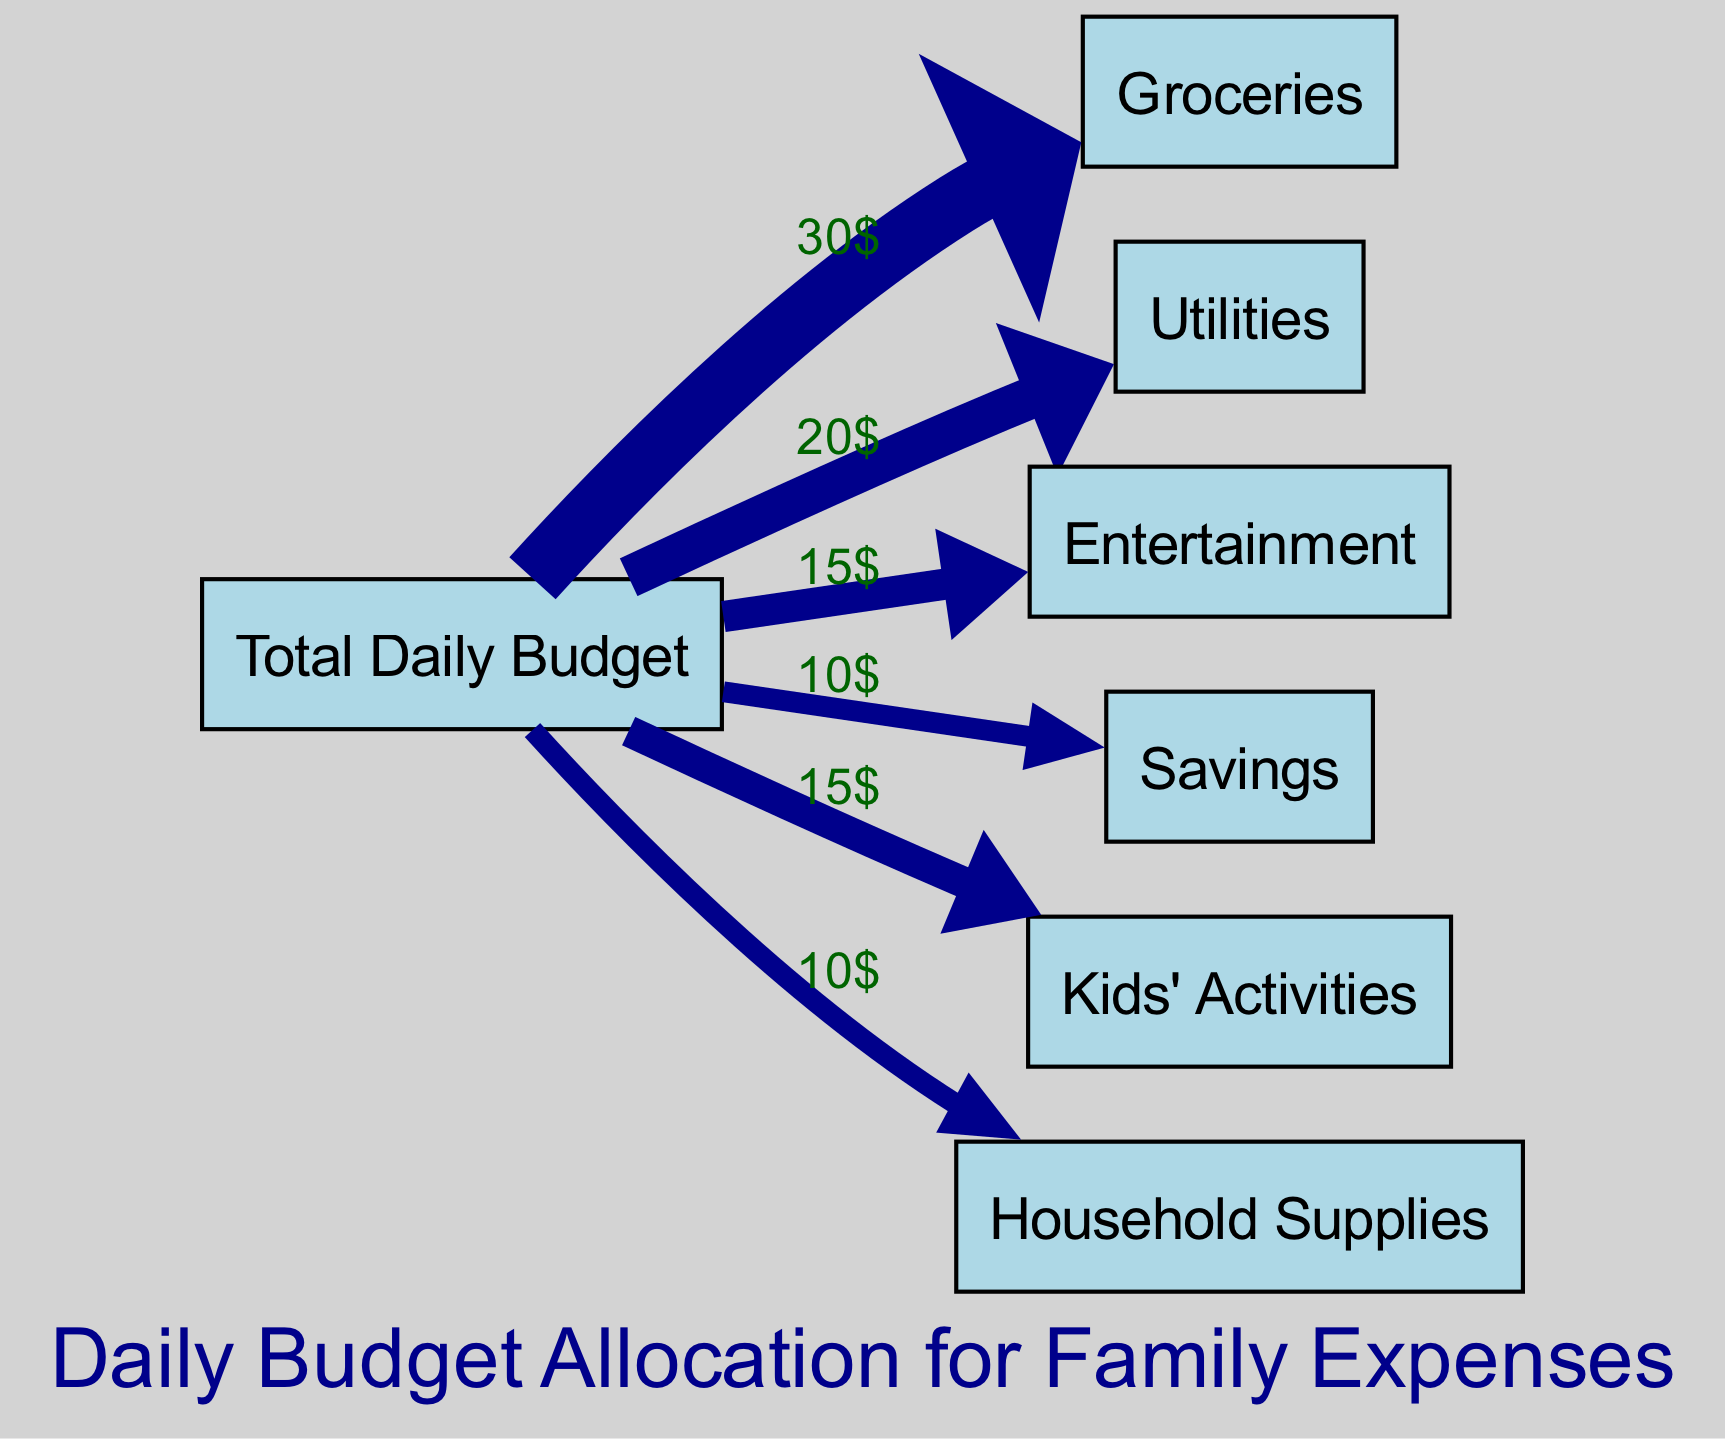What is the total value allocated to groceries? The diagram indicates that the link from "Total Daily Budget" to "Groceries" has a value of 30, which directly represents the amount allocated to groceries.
Answer: 30 How much money is allocated to kids' activities? From the diagram, the link from "Total Daily Budget" to "Kids' Activities" shows a value of 15, indicating the budget allocated for kids' activities.
Answer: 15 What is the percentage of the budget allocated to savings compared to the total daily budget? The savings allocation value is 10. First, we calculate the total daily budget by summing all allocations: 30 + 20 + 15 + 10 + 15 + 10 = 100. Then, we calculate the percentage: (10/100) * 100 = 10%.
Answer: 10% Which category has the highest allocation? By examining the values for each category, we see that "Groceries" has the highest allocation at 30, compared to others: 20 for Utilities, 15 for Entertainment and Kids' Activities, and 10 for both Savings and Household Supplies.
Answer: Groceries What is the total number of categories this budget is split into? The diagram lists 6 different target categories that make up the budget, which includes Groceries, Utilities, Entertainment, Savings, Kids' Activities, and Household Supplies.
Answer: 6 Which two categories have the same allocation value? According to the diagram, both "Savings" and "Household Supplies" have an allocation of 10. This can be verified by examining the links leading from the "Total Daily Budget" to each category.
Answer: Savings and Household Supplies 